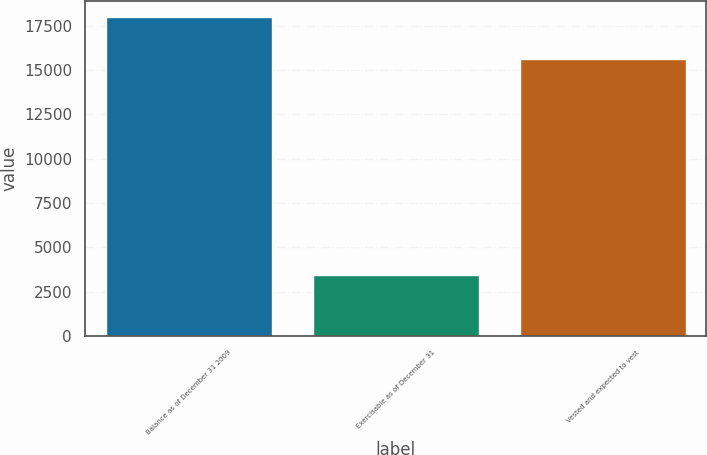<chart> <loc_0><loc_0><loc_500><loc_500><bar_chart><fcel>Balance as of December 31 2009<fcel>Exercisable as of December 31<fcel>Vested and expected to vest<nl><fcel>18001<fcel>3446<fcel>15610<nl></chart> 